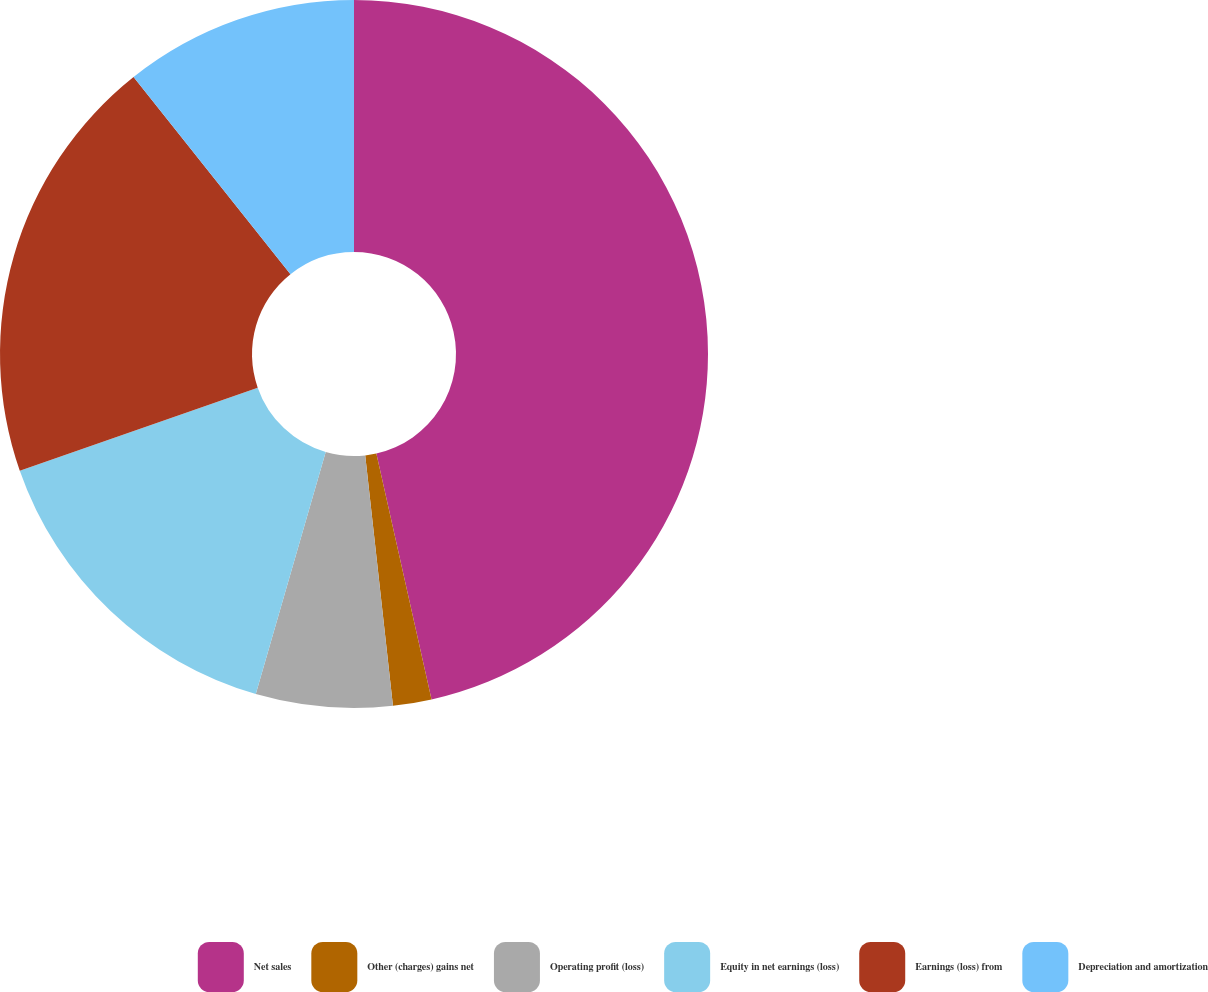Convert chart. <chart><loc_0><loc_0><loc_500><loc_500><pie_chart><fcel>Net sales<fcel>Other (charges) gains net<fcel>Operating profit (loss)<fcel>Equity in net earnings (loss)<fcel>Earnings (loss) from<fcel>Depreciation and amortization<nl><fcel>46.49%<fcel>1.76%<fcel>6.23%<fcel>15.18%<fcel>19.65%<fcel>10.7%<nl></chart> 